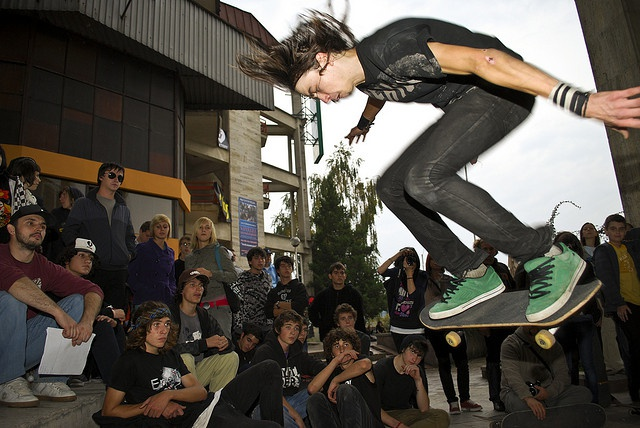Describe the objects in this image and their specific colors. I can see people in black, gray, and white tones, people in black, maroon, and gray tones, people in black, maroon, and gray tones, people in black, gray, and maroon tones, and people in black, maroon, and brown tones in this image. 